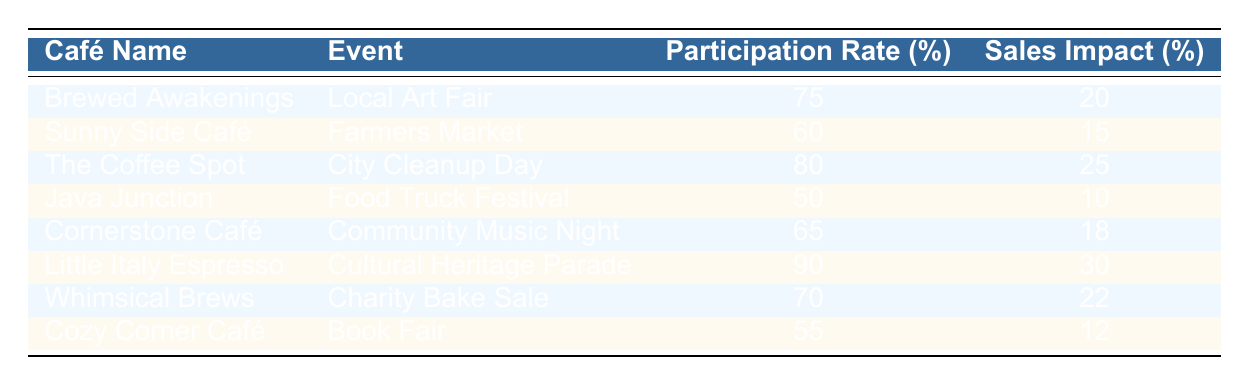What is the highest participation rate among the cafés? Looking at the Participation Rate column, the highest value is 90%, which belongs to Little Italy Espresso.
Answer: 90% Which café experiences a sales impact of 22%? By scanning the Sales Impact column, Whimsical Brews is identified as the café with a 22% sales impact.
Answer: Whimsical Brews What is the average sales impact of all the cafés? To find the average, sum the Sales Impact values: (20 + 15 + 25 + 10 + 18 + 30 + 22 + 12) = 152. There are 8 cafés, so the average is 152/8 = 19.
Answer: 19 Is there a café with a participation rate of less than 60%? Yes, Java Junction has a participation rate of 50%, which is less than 60%.
Answer: Yes Which event has the highest participation rate, and what is the corresponding café? Comparing the Participation Rates, Little Italy Espresso participates in the Cultural Heritage Parade with the highest rate of 90%.
Answer: Little Italy Espresso, Cultural Heritage Parade What is the total sales impact of cafés that participated in events with a participation rate of 70% or more? The cafés with 70% or more participation are Brewed Awakenings (20%), The Coffee Spot (25%), Little Italy Espresso (30%), and Whimsical Brews (22%). The total sales impact is 20 + 25 + 30 + 22 = 97%.
Answer: 97% Does Cornerstone Café have a higher sales impact compared to Cozy Corner Café? Yes, Cornerstone Café has an 18% sales impact, while Cozy Corner Café has a 12% sales impact, which is lower.
Answer: Yes Which café had the least sales impact, and what was that impact? By checking the Sales Impact column, Java Junction has the least at 10%.
Answer: Java Junction, 10% 